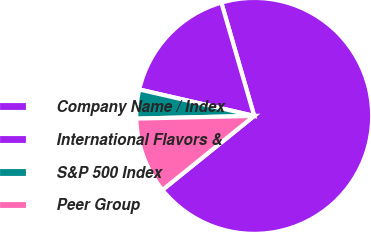Convert chart. <chart><loc_0><loc_0><loc_500><loc_500><pie_chart><fcel>Company Name / Index<fcel>International Flavors &<fcel>S&P 500 Index<fcel>Peer Group<nl><fcel>68.69%<fcel>16.91%<fcel>3.96%<fcel>10.44%<nl></chart> 